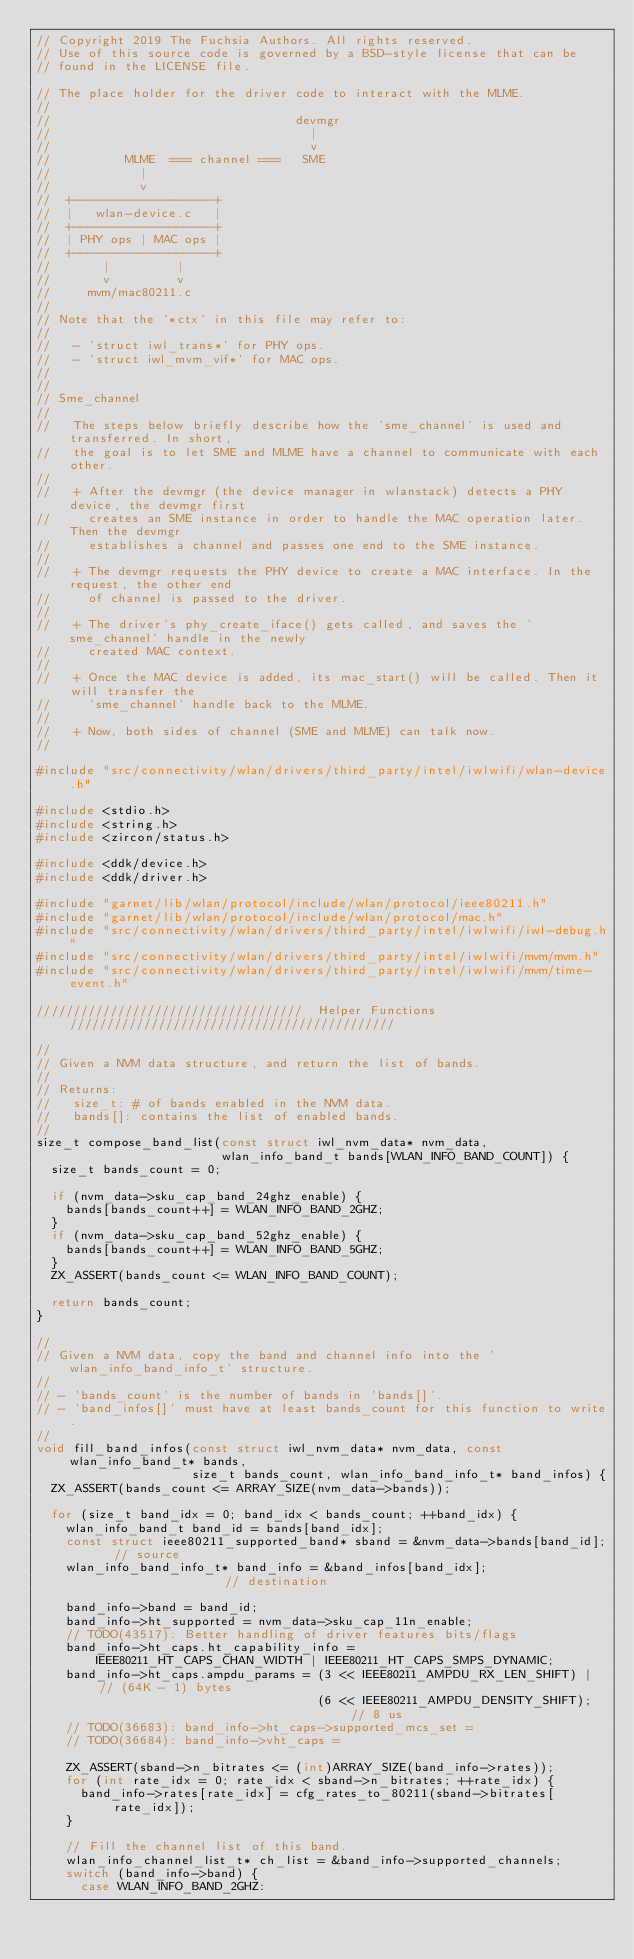Convert code to text. <code><loc_0><loc_0><loc_500><loc_500><_C_>// Copyright 2019 The Fuchsia Authors. All rights reserved.
// Use of this source code is governed by a BSD-style license that can be
// found in the LICENSE file.

// The place holder for the driver code to interact with the MLME.
//
//                                 devmgr
//                                   |
//                                   v
//          MLME  === channel ===   SME
//            |
//            v
//  +-------------------+
//  |   wlan-device.c   |
//  +-------------------+
//  | PHY ops | MAC ops |
//  +-------------------+
//       |         |
//       v         v
//     mvm/mac80211.c
//
// Note that the '*ctx' in this file may refer to:
//
//   - 'struct iwl_trans*' for PHY ops.
//   - 'struct iwl_mvm_vif*' for MAC ops.
//
//
// Sme_channel
//
//   The steps below briefly describe how the 'sme_channel' is used and transferred. In short,
//   the goal is to let SME and MLME have a channel to communicate with each other.
//
//   + After the devmgr (the device manager in wlanstack) detects a PHY device, the devmgr first
//     creates an SME instance in order to handle the MAC operation later. Then the devmgr
//     establishes a channel and passes one end to the SME instance.
//
//   + The devmgr requests the PHY device to create a MAC interface. In the request, the other end
//     of channel is passed to the driver.
//
//   + The driver's phy_create_iface() gets called, and saves the 'sme_channel' handle in the newly
//     created MAC context.
//
//   + Once the MAC device is added, its mac_start() will be called. Then it will transfer the
//     'sme_channel' handle back to the MLME.
//
//   + Now, both sides of channel (SME and MLME) can talk now.
//

#include "src/connectivity/wlan/drivers/third_party/intel/iwlwifi/wlan-device.h"

#include <stdio.h>
#include <string.h>
#include <zircon/status.h>

#include <ddk/device.h>
#include <ddk/driver.h>

#include "garnet/lib/wlan/protocol/include/wlan/protocol/ieee80211.h"
#include "garnet/lib/wlan/protocol/include/wlan/protocol/mac.h"
#include "src/connectivity/wlan/drivers/third_party/intel/iwlwifi/iwl-debug.h"
#include "src/connectivity/wlan/drivers/third_party/intel/iwlwifi/mvm/mvm.h"
#include "src/connectivity/wlan/drivers/third_party/intel/iwlwifi/mvm/time-event.h"

////////////////////////////////////  Helper Functions  ////////////////////////////////////////////

//
// Given a NVM data structure, and return the list of bands.
//
// Returns:
//   size_t: # of bands enabled in the NVM data.
//   bands[]: contains the list of enabled bands.
//
size_t compose_band_list(const struct iwl_nvm_data* nvm_data,
                         wlan_info_band_t bands[WLAN_INFO_BAND_COUNT]) {
  size_t bands_count = 0;

  if (nvm_data->sku_cap_band_24ghz_enable) {
    bands[bands_count++] = WLAN_INFO_BAND_2GHZ;
  }
  if (nvm_data->sku_cap_band_52ghz_enable) {
    bands[bands_count++] = WLAN_INFO_BAND_5GHZ;
  }
  ZX_ASSERT(bands_count <= WLAN_INFO_BAND_COUNT);

  return bands_count;
}

//
// Given a NVM data, copy the band and channel info into the 'wlan_info_band_info_t' structure.
//
// - 'bands_count' is the number of bands in 'bands[]'.
// - 'band_infos[]' must have at least bands_count for this function to write.
//
void fill_band_infos(const struct iwl_nvm_data* nvm_data, const wlan_info_band_t* bands,
                     size_t bands_count, wlan_info_band_info_t* band_infos) {
  ZX_ASSERT(bands_count <= ARRAY_SIZE(nvm_data->bands));

  for (size_t band_idx = 0; band_idx < bands_count; ++band_idx) {
    wlan_info_band_t band_id = bands[band_idx];
    const struct ieee80211_supported_band* sband = &nvm_data->bands[band_id];  // source
    wlan_info_band_info_t* band_info = &band_infos[band_idx];                  // destination

    band_info->band = band_id;
    band_info->ht_supported = nvm_data->sku_cap_11n_enable;
    // TODO(43517): Better handling of driver features bits/flags
    band_info->ht_caps.ht_capability_info =
        IEEE80211_HT_CAPS_CHAN_WIDTH | IEEE80211_HT_CAPS_SMPS_DYNAMIC;
    band_info->ht_caps.ampdu_params = (3 << IEEE80211_AMPDU_RX_LEN_SHIFT) |  // (64K - 1) bytes
                                      (6 << IEEE80211_AMPDU_DENSITY_SHIFT);  // 8 us
    // TODO(36683): band_info->ht_caps->supported_mcs_set =
    // TODO(36684): band_info->vht_caps =

    ZX_ASSERT(sband->n_bitrates <= (int)ARRAY_SIZE(band_info->rates));
    for (int rate_idx = 0; rate_idx < sband->n_bitrates; ++rate_idx) {
      band_info->rates[rate_idx] = cfg_rates_to_80211(sband->bitrates[rate_idx]);
    }

    // Fill the channel list of this band.
    wlan_info_channel_list_t* ch_list = &band_info->supported_channels;
    switch (band_info->band) {
      case WLAN_INFO_BAND_2GHZ:</code> 